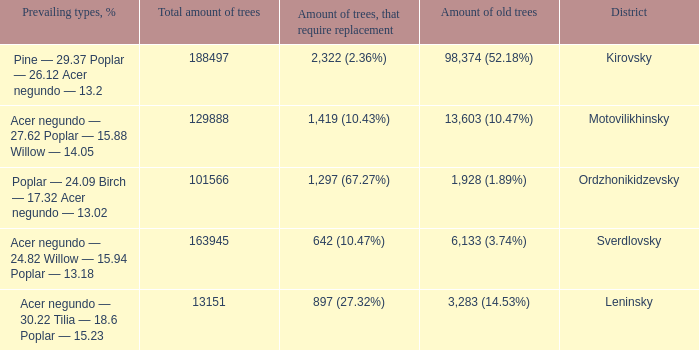What is the total amount of trees when district is leninsky? 13151.0. 